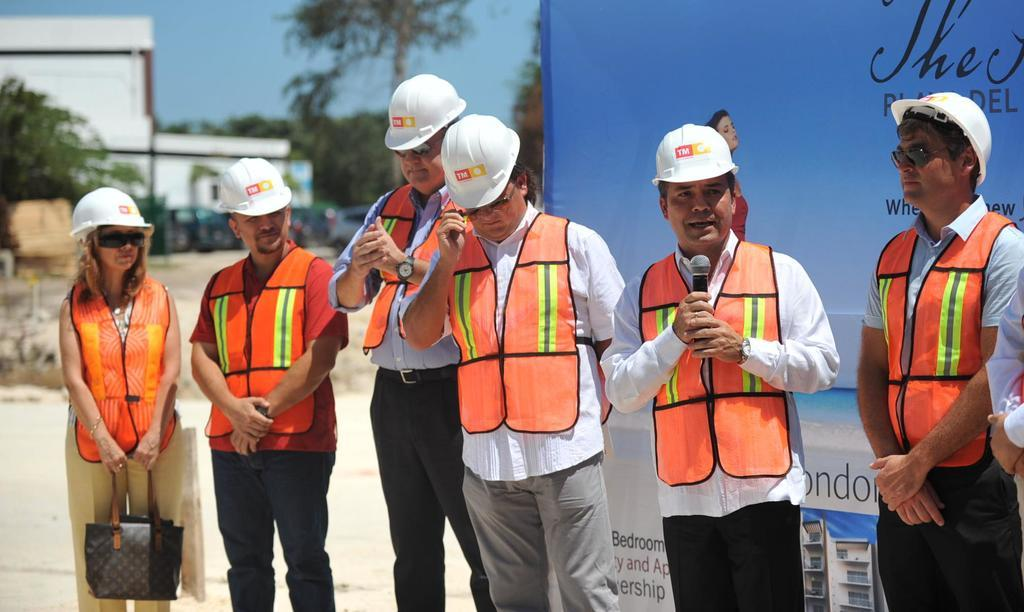How many people are in the image? There is a group of people in the image, but the exact number is not specified. What is hanging or displayed in the image? There is a banner in the image. What type of natural environment is visible in the image? There are trees in the image. What type of structure is present in the image? There is a building in the image. What is visible at the top of the image? The sky is visible at the top of the image. What book is being read by the trees in the image? There is no book present in the image, and trees do not read books. What is the tendency of the icicles in the image? There are no icicles present in the image. 